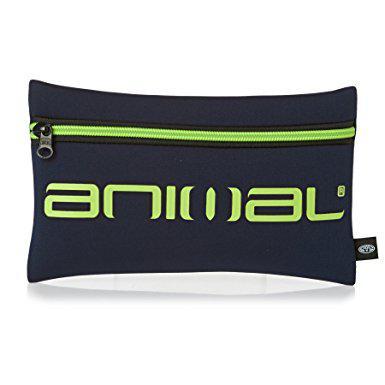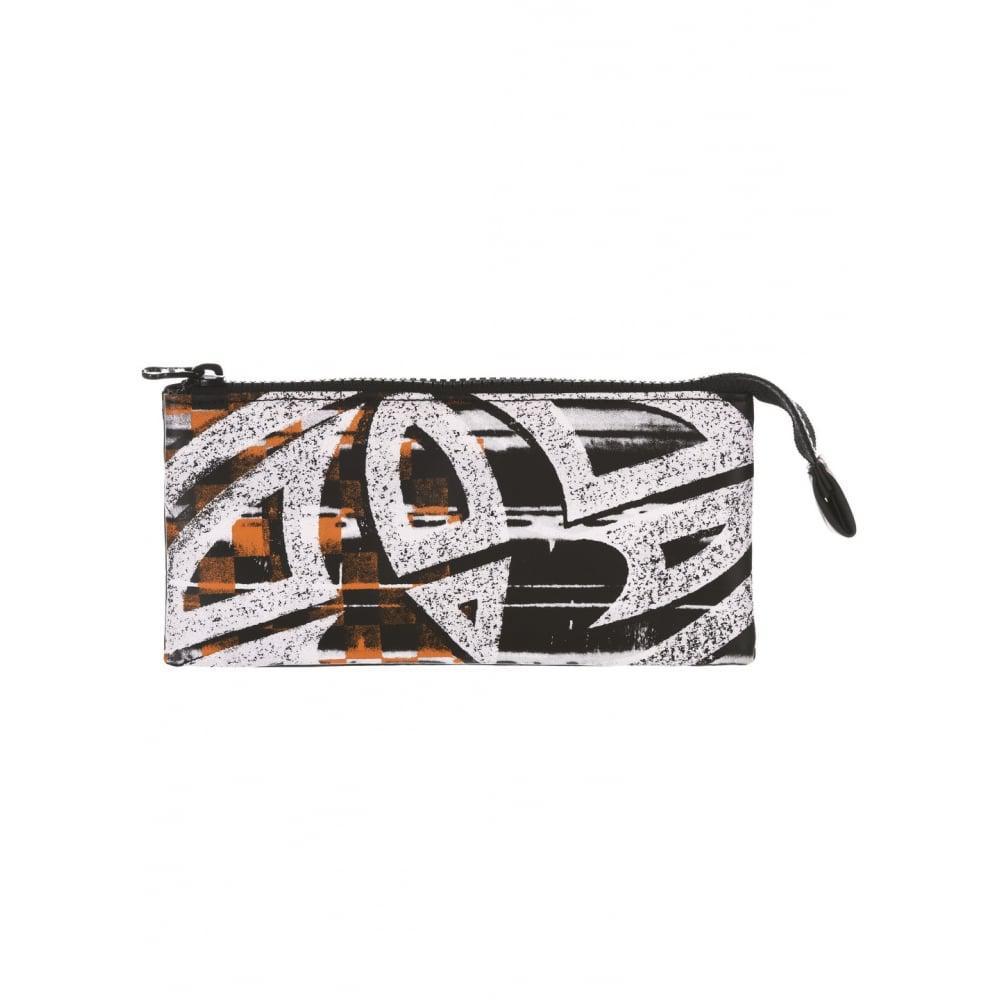The first image is the image on the left, the second image is the image on the right. For the images displayed, is the sentence "At least one of the pencil cases is red, and all pencil cases with a visible front feature bold lettering." factually correct? Answer yes or no. No. 